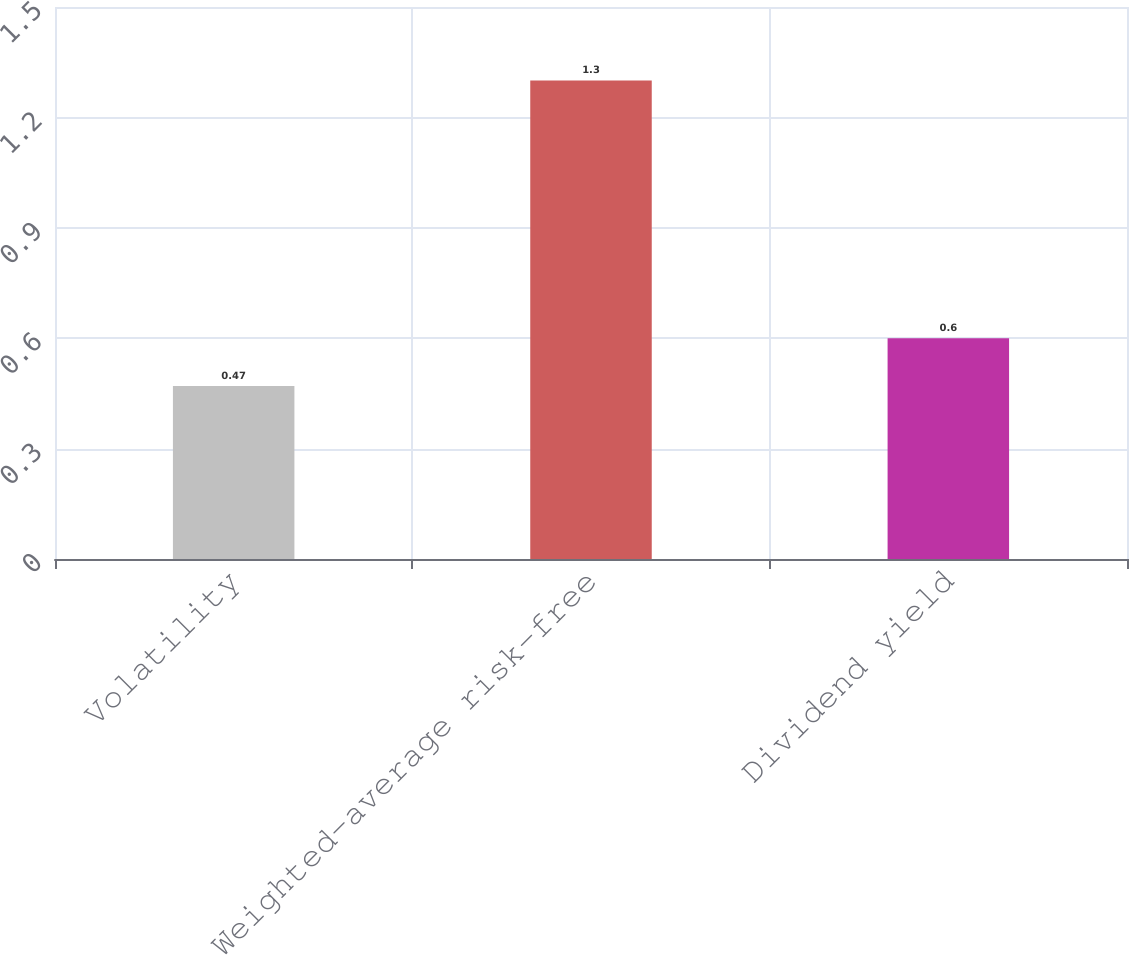<chart> <loc_0><loc_0><loc_500><loc_500><bar_chart><fcel>Volatility<fcel>Weighted-average risk-free<fcel>Dividend yield<nl><fcel>0.47<fcel>1.3<fcel>0.6<nl></chart> 